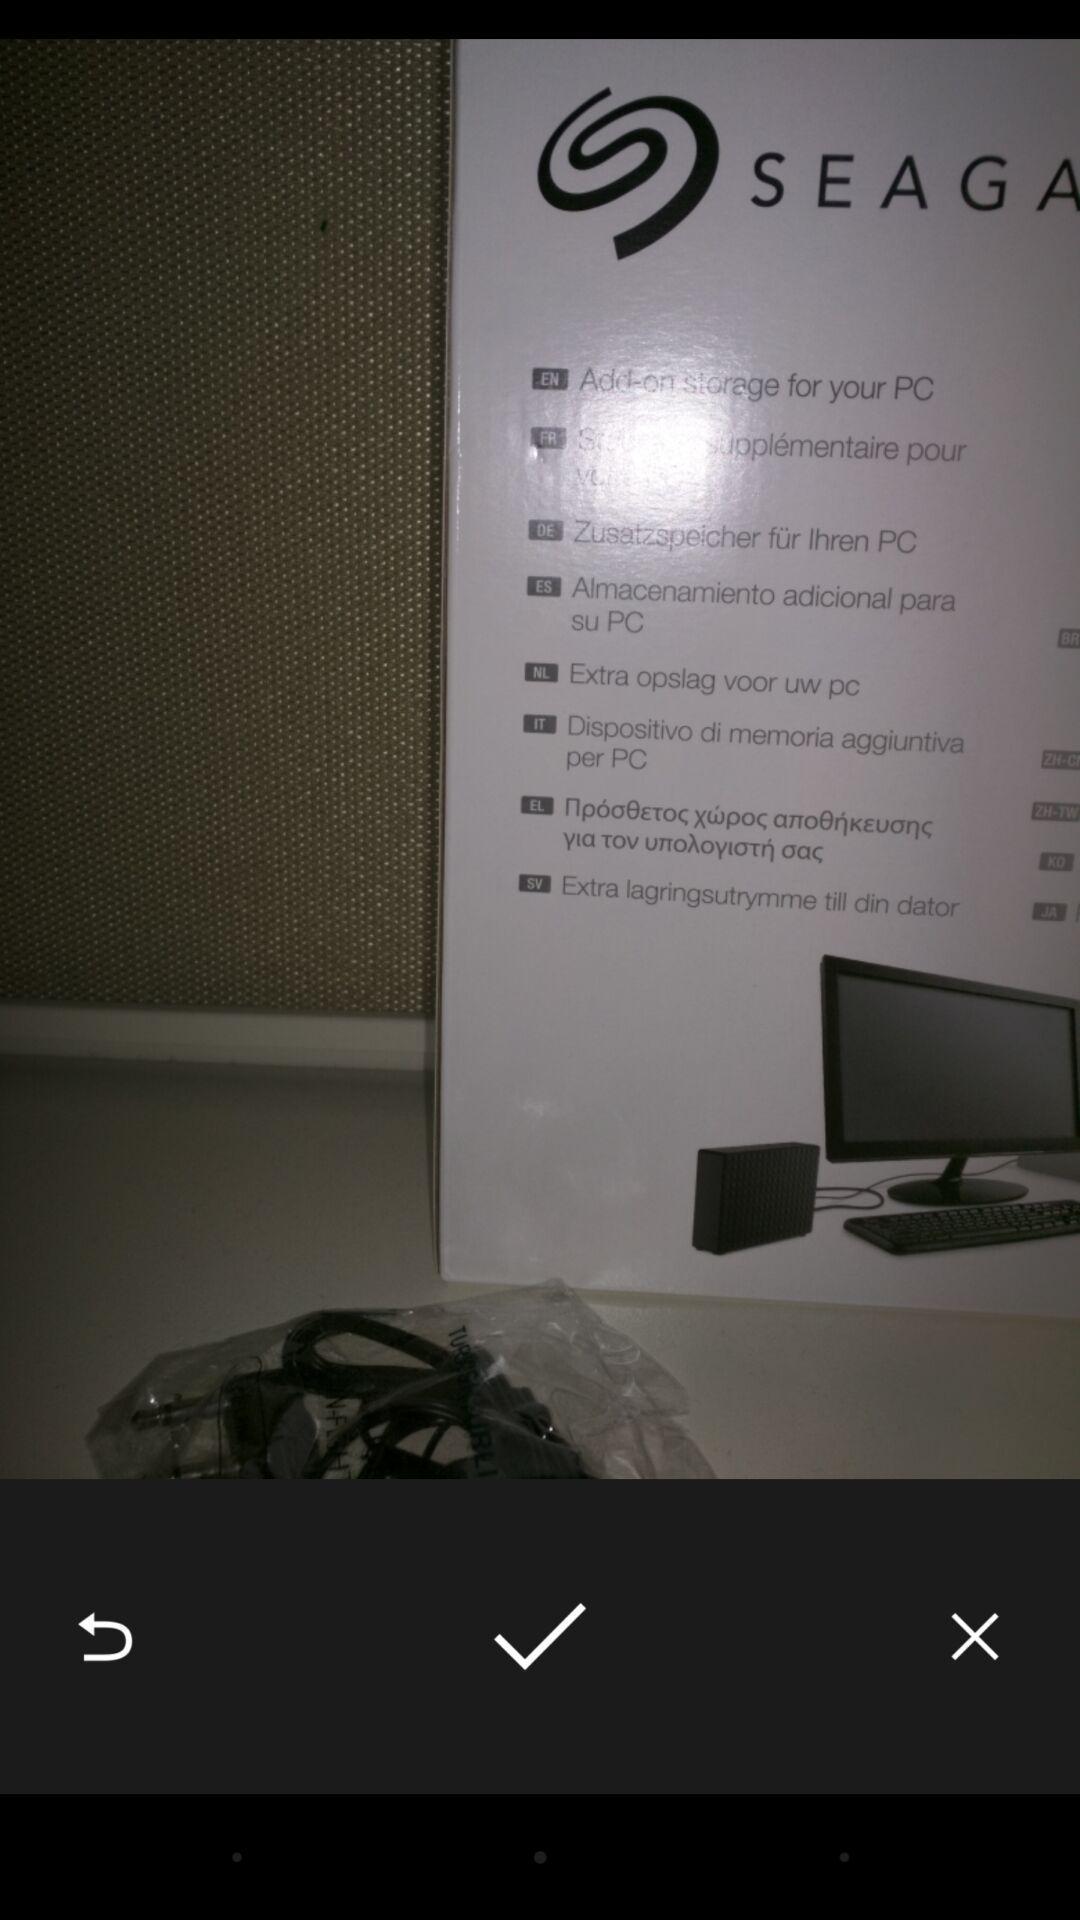Tell me about the visual elements in this screen capture. Page to accept an image. 